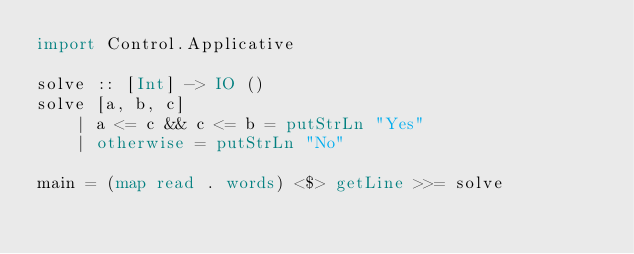Convert code to text. <code><loc_0><loc_0><loc_500><loc_500><_Haskell_>import Control.Applicative

solve :: [Int] -> IO ()
solve [a, b, c]
    | a <= c && c <= b = putStrLn "Yes"
    | otherwise = putStrLn "No"

main = (map read . words) <$> getLine >>= solve</code> 